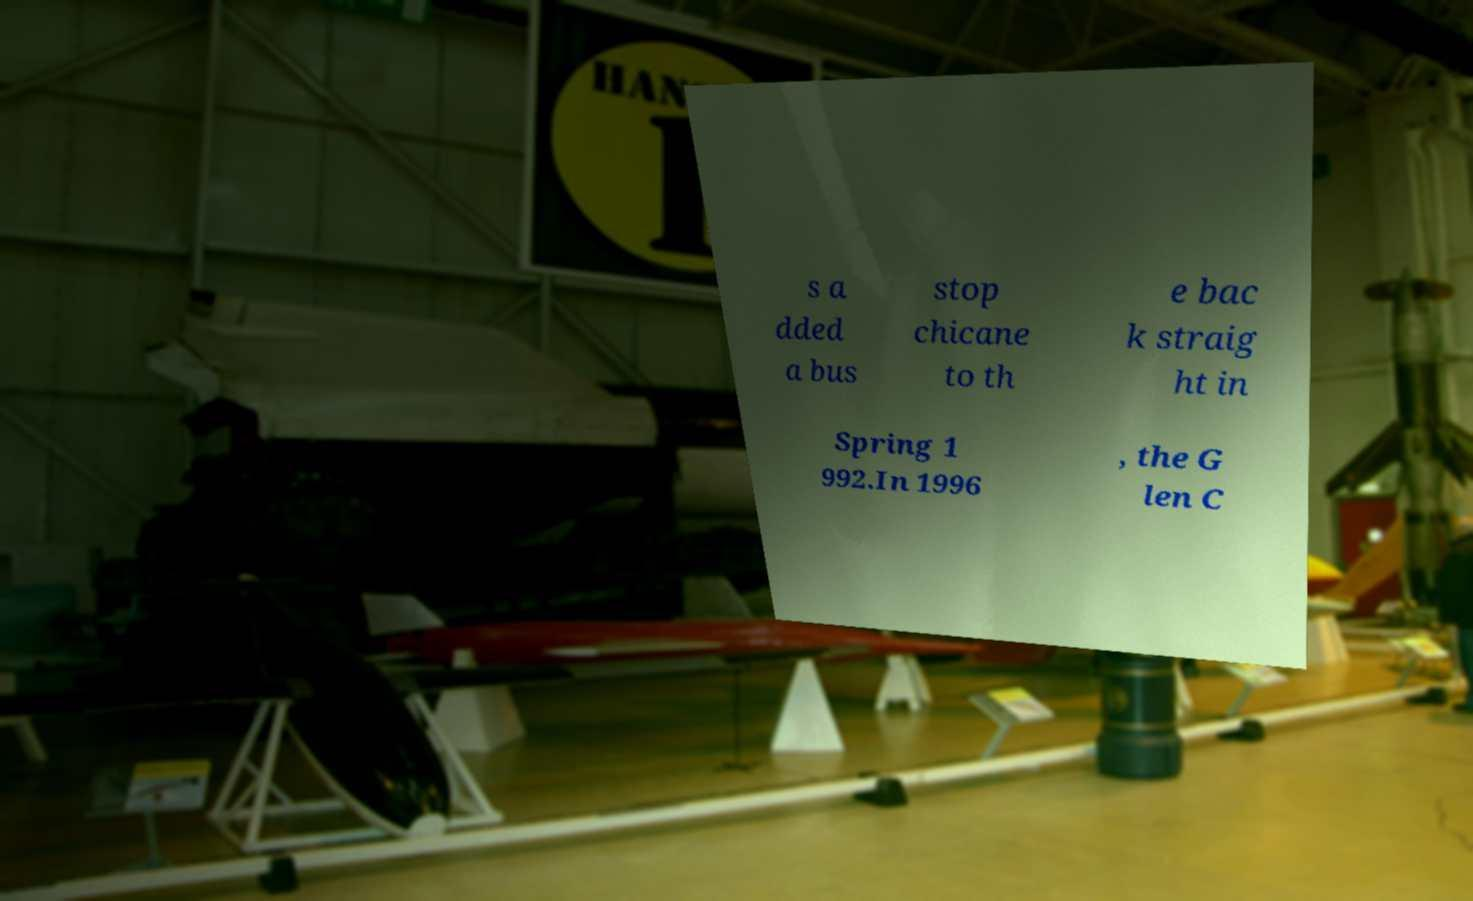For documentation purposes, I need the text within this image transcribed. Could you provide that? s a dded a bus stop chicane to th e bac k straig ht in Spring 1 992.In 1996 , the G len C 